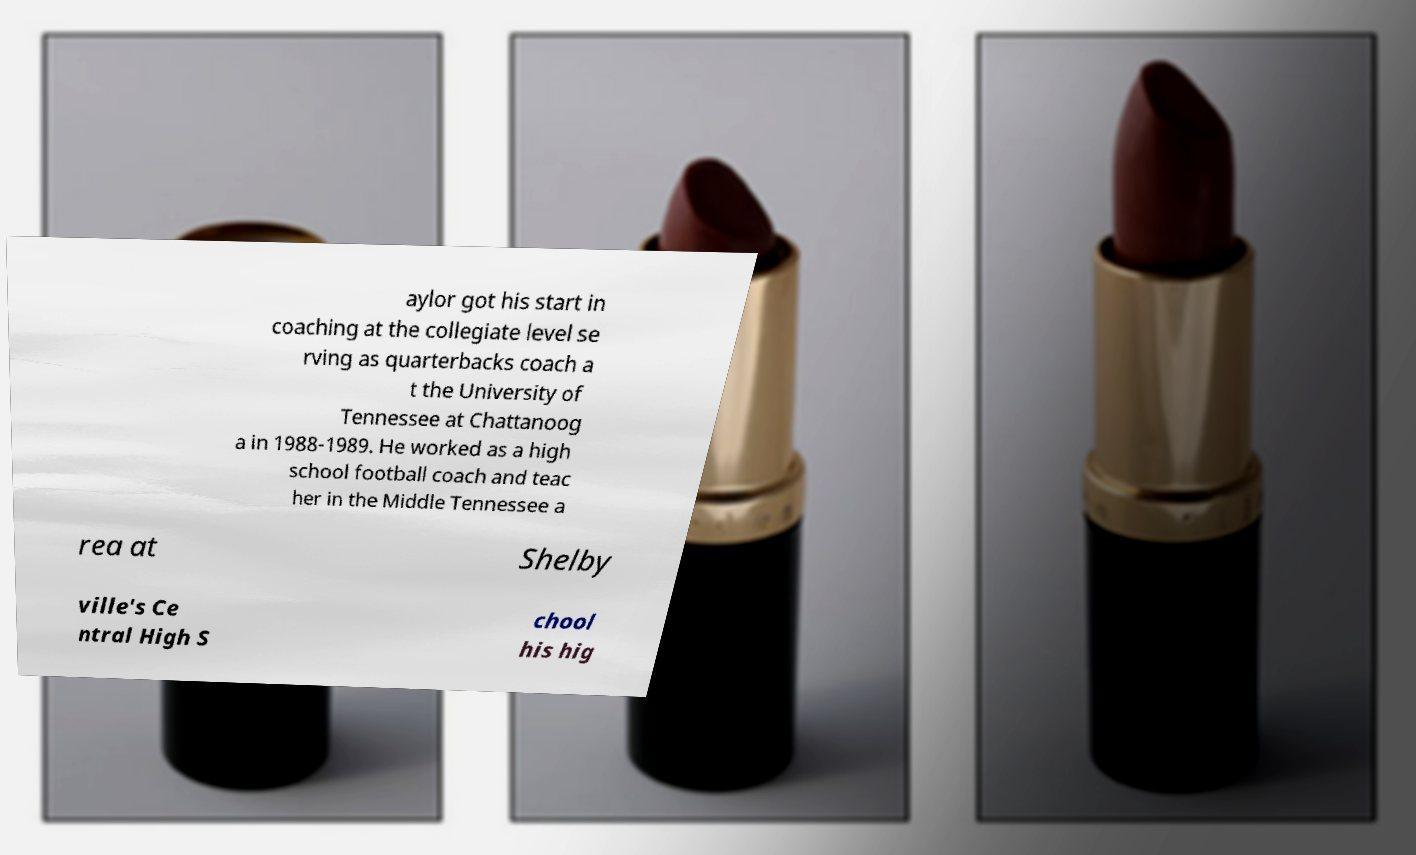Could you extract and type out the text from this image? aylor got his start in coaching at the collegiate level se rving as quarterbacks coach a t the University of Tennessee at Chattanoog a in 1988-1989. He worked as a high school football coach and teac her in the Middle Tennessee a rea at Shelby ville's Ce ntral High S chool his hig 